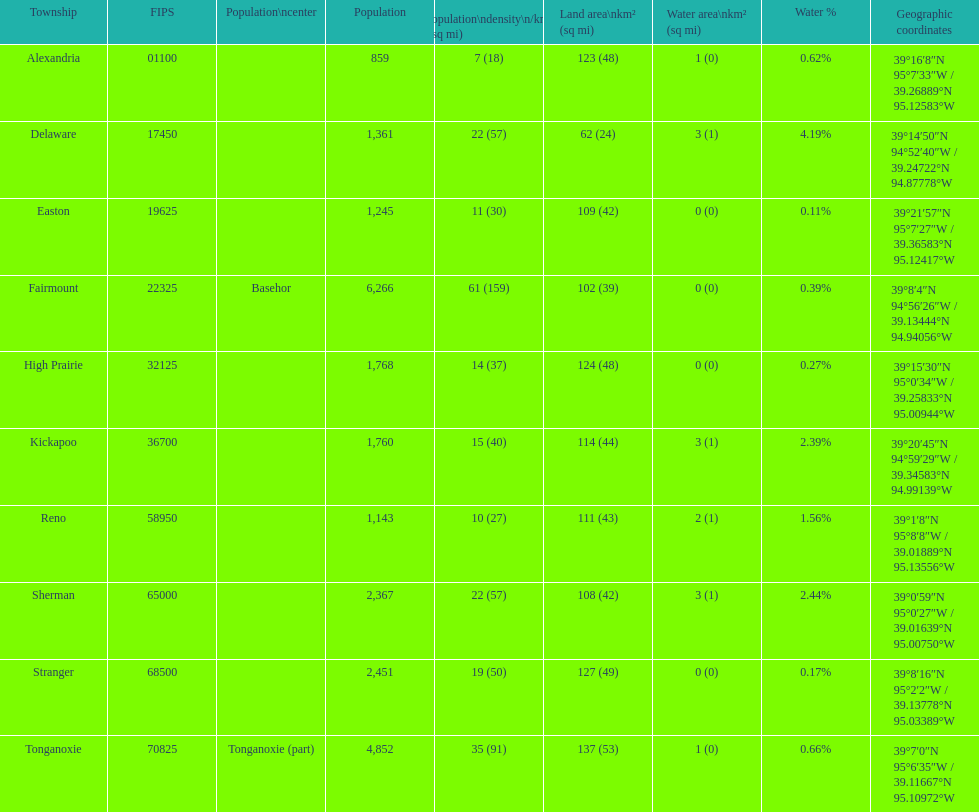What is the number of townships with populations exceeding 2,000? 4. 